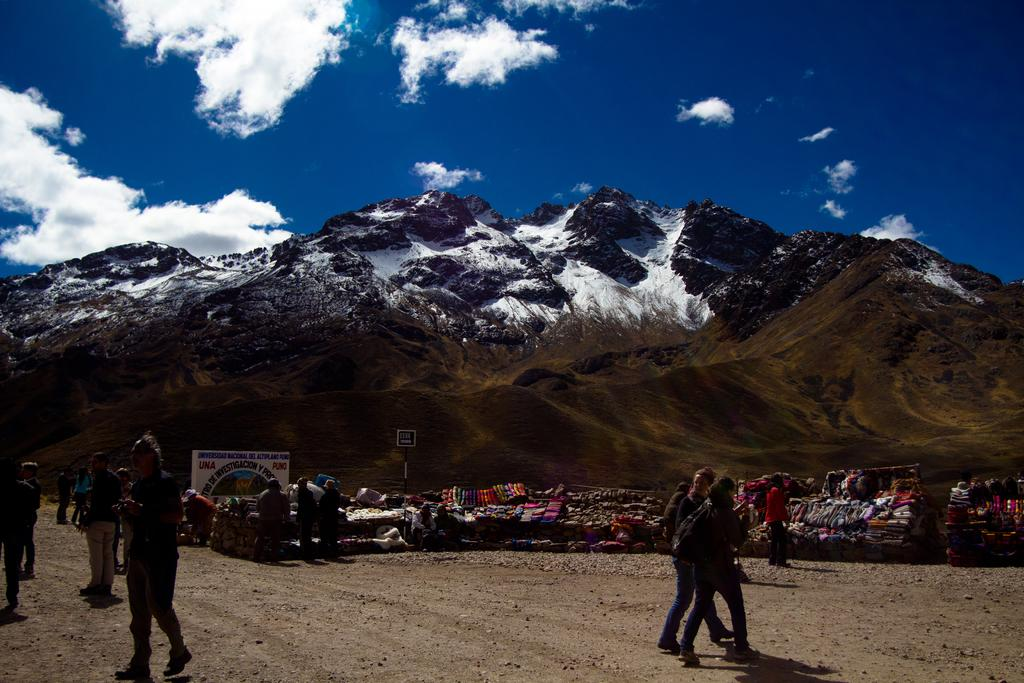Who or what can be seen in the image? There are people in the image. What can be seen in the background of the image? There are clothes, a hoarding, hills, and clouds visible in the background of the image. What type of doctor is treating the people in the image? There is no doctor present in the image, and the people are not being treated. 